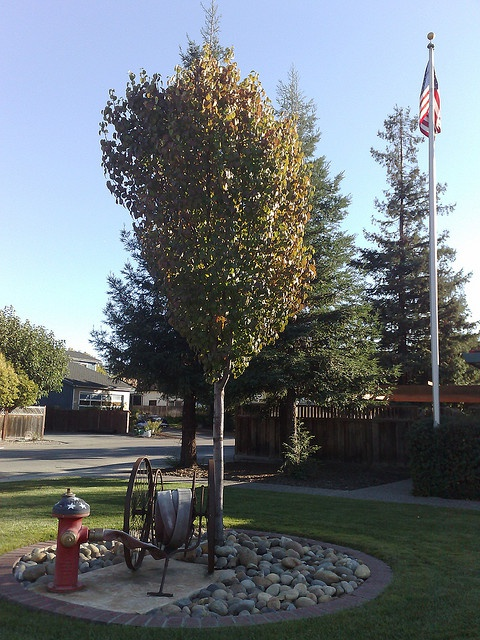Describe the objects in this image and their specific colors. I can see a fire hydrant in lavender, maroon, black, and gray tones in this image. 